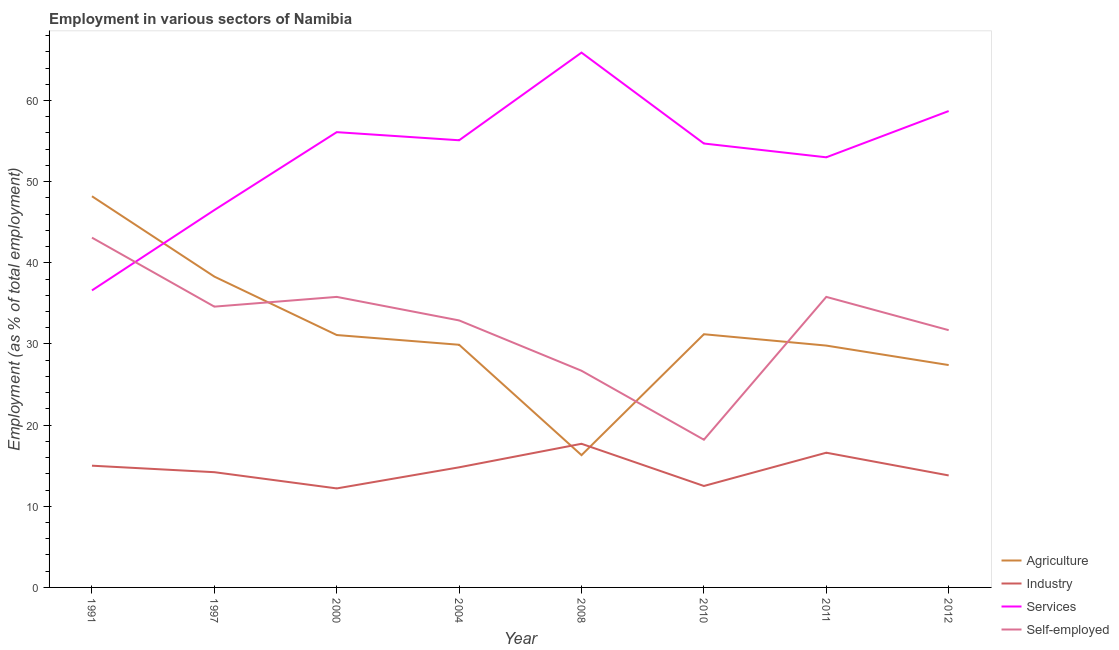How many different coloured lines are there?
Make the answer very short. 4. Is the number of lines equal to the number of legend labels?
Your answer should be very brief. Yes. What is the percentage of workers in industry in 2004?
Make the answer very short. 14.8. Across all years, what is the maximum percentage of workers in industry?
Provide a succinct answer. 17.7. Across all years, what is the minimum percentage of workers in services?
Offer a very short reply. 36.6. In which year was the percentage of workers in industry maximum?
Provide a short and direct response. 2008. What is the total percentage of workers in services in the graph?
Your answer should be very brief. 426.6. What is the difference between the percentage of workers in industry in 2008 and that in 2012?
Your response must be concise. 3.9. What is the difference between the percentage of workers in services in 1997 and the percentage of workers in agriculture in 2008?
Offer a terse response. 30.2. What is the average percentage of self employed workers per year?
Offer a very short reply. 32.35. In the year 2010, what is the difference between the percentage of workers in services and percentage of workers in industry?
Make the answer very short. 42.2. What is the ratio of the percentage of self employed workers in 1991 to that in 2000?
Your answer should be compact. 1.2. Is the percentage of workers in agriculture in 2010 less than that in 2011?
Give a very brief answer. No. Is the difference between the percentage of workers in services in 1991 and 2010 greater than the difference between the percentage of self employed workers in 1991 and 2010?
Provide a short and direct response. No. What is the difference between the highest and the second highest percentage of workers in services?
Provide a succinct answer. 7.2. What is the difference between the highest and the lowest percentage of workers in agriculture?
Make the answer very short. 31.9. In how many years, is the percentage of self employed workers greater than the average percentage of self employed workers taken over all years?
Offer a very short reply. 5. Is the sum of the percentage of workers in services in 1991 and 2012 greater than the maximum percentage of workers in industry across all years?
Provide a short and direct response. Yes. How many years are there in the graph?
Your answer should be very brief. 8. Does the graph contain grids?
Your answer should be compact. No. How are the legend labels stacked?
Keep it short and to the point. Vertical. What is the title of the graph?
Your response must be concise. Employment in various sectors of Namibia. Does "Subsidies and Transfers" appear as one of the legend labels in the graph?
Keep it short and to the point. No. What is the label or title of the X-axis?
Provide a succinct answer. Year. What is the label or title of the Y-axis?
Keep it short and to the point. Employment (as % of total employment). What is the Employment (as % of total employment) of Agriculture in 1991?
Offer a very short reply. 48.2. What is the Employment (as % of total employment) of Industry in 1991?
Offer a very short reply. 15. What is the Employment (as % of total employment) in Services in 1991?
Ensure brevity in your answer.  36.6. What is the Employment (as % of total employment) in Self-employed in 1991?
Provide a short and direct response. 43.1. What is the Employment (as % of total employment) in Agriculture in 1997?
Provide a short and direct response. 38.3. What is the Employment (as % of total employment) of Industry in 1997?
Give a very brief answer. 14.2. What is the Employment (as % of total employment) of Services in 1997?
Keep it short and to the point. 46.5. What is the Employment (as % of total employment) of Self-employed in 1997?
Your response must be concise. 34.6. What is the Employment (as % of total employment) of Agriculture in 2000?
Make the answer very short. 31.1. What is the Employment (as % of total employment) in Industry in 2000?
Provide a short and direct response. 12.2. What is the Employment (as % of total employment) of Services in 2000?
Keep it short and to the point. 56.1. What is the Employment (as % of total employment) of Self-employed in 2000?
Your answer should be very brief. 35.8. What is the Employment (as % of total employment) in Agriculture in 2004?
Your answer should be compact. 29.9. What is the Employment (as % of total employment) in Industry in 2004?
Give a very brief answer. 14.8. What is the Employment (as % of total employment) of Services in 2004?
Offer a terse response. 55.1. What is the Employment (as % of total employment) of Self-employed in 2004?
Offer a very short reply. 32.9. What is the Employment (as % of total employment) in Agriculture in 2008?
Ensure brevity in your answer.  16.3. What is the Employment (as % of total employment) of Industry in 2008?
Offer a very short reply. 17.7. What is the Employment (as % of total employment) of Services in 2008?
Ensure brevity in your answer.  65.9. What is the Employment (as % of total employment) of Self-employed in 2008?
Your answer should be compact. 26.7. What is the Employment (as % of total employment) in Agriculture in 2010?
Provide a succinct answer. 31.2. What is the Employment (as % of total employment) in Services in 2010?
Offer a terse response. 54.7. What is the Employment (as % of total employment) in Self-employed in 2010?
Offer a terse response. 18.2. What is the Employment (as % of total employment) in Agriculture in 2011?
Make the answer very short. 29.8. What is the Employment (as % of total employment) in Industry in 2011?
Ensure brevity in your answer.  16.6. What is the Employment (as % of total employment) in Services in 2011?
Keep it short and to the point. 53. What is the Employment (as % of total employment) of Self-employed in 2011?
Ensure brevity in your answer.  35.8. What is the Employment (as % of total employment) of Agriculture in 2012?
Offer a terse response. 27.4. What is the Employment (as % of total employment) of Industry in 2012?
Your answer should be very brief. 13.8. What is the Employment (as % of total employment) of Services in 2012?
Your answer should be very brief. 58.7. What is the Employment (as % of total employment) in Self-employed in 2012?
Your answer should be very brief. 31.7. Across all years, what is the maximum Employment (as % of total employment) of Agriculture?
Give a very brief answer. 48.2. Across all years, what is the maximum Employment (as % of total employment) in Industry?
Your answer should be compact. 17.7. Across all years, what is the maximum Employment (as % of total employment) of Services?
Ensure brevity in your answer.  65.9. Across all years, what is the maximum Employment (as % of total employment) in Self-employed?
Your response must be concise. 43.1. Across all years, what is the minimum Employment (as % of total employment) of Agriculture?
Your response must be concise. 16.3. Across all years, what is the minimum Employment (as % of total employment) in Industry?
Your response must be concise. 12.2. Across all years, what is the minimum Employment (as % of total employment) of Services?
Make the answer very short. 36.6. Across all years, what is the minimum Employment (as % of total employment) in Self-employed?
Your answer should be compact. 18.2. What is the total Employment (as % of total employment) of Agriculture in the graph?
Give a very brief answer. 252.2. What is the total Employment (as % of total employment) in Industry in the graph?
Ensure brevity in your answer.  116.8. What is the total Employment (as % of total employment) of Services in the graph?
Provide a succinct answer. 426.6. What is the total Employment (as % of total employment) in Self-employed in the graph?
Your answer should be very brief. 258.8. What is the difference between the Employment (as % of total employment) of Agriculture in 1991 and that in 1997?
Ensure brevity in your answer.  9.9. What is the difference between the Employment (as % of total employment) of Services in 1991 and that in 1997?
Offer a very short reply. -9.9. What is the difference between the Employment (as % of total employment) in Agriculture in 1991 and that in 2000?
Offer a terse response. 17.1. What is the difference between the Employment (as % of total employment) in Industry in 1991 and that in 2000?
Make the answer very short. 2.8. What is the difference between the Employment (as % of total employment) of Services in 1991 and that in 2000?
Make the answer very short. -19.5. What is the difference between the Employment (as % of total employment) in Self-employed in 1991 and that in 2000?
Make the answer very short. 7.3. What is the difference between the Employment (as % of total employment) of Industry in 1991 and that in 2004?
Provide a short and direct response. 0.2. What is the difference between the Employment (as % of total employment) of Services in 1991 and that in 2004?
Your answer should be very brief. -18.5. What is the difference between the Employment (as % of total employment) of Self-employed in 1991 and that in 2004?
Your response must be concise. 10.2. What is the difference between the Employment (as % of total employment) of Agriculture in 1991 and that in 2008?
Ensure brevity in your answer.  31.9. What is the difference between the Employment (as % of total employment) of Services in 1991 and that in 2008?
Your answer should be very brief. -29.3. What is the difference between the Employment (as % of total employment) of Agriculture in 1991 and that in 2010?
Provide a succinct answer. 17. What is the difference between the Employment (as % of total employment) of Services in 1991 and that in 2010?
Offer a very short reply. -18.1. What is the difference between the Employment (as % of total employment) in Self-employed in 1991 and that in 2010?
Ensure brevity in your answer.  24.9. What is the difference between the Employment (as % of total employment) in Industry in 1991 and that in 2011?
Provide a succinct answer. -1.6. What is the difference between the Employment (as % of total employment) of Services in 1991 and that in 2011?
Provide a short and direct response. -16.4. What is the difference between the Employment (as % of total employment) in Agriculture in 1991 and that in 2012?
Offer a very short reply. 20.8. What is the difference between the Employment (as % of total employment) in Services in 1991 and that in 2012?
Offer a very short reply. -22.1. What is the difference between the Employment (as % of total employment) in Self-employed in 1991 and that in 2012?
Provide a short and direct response. 11.4. What is the difference between the Employment (as % of total employment) of Industry in 1997 and that in 2004?
Offer a very short reply. -0.6. What is the difference between the Employment (as % of total employment) in Services in 1997 and that in 2004?
Your answer should be compact. -8.6. What is the difference between the Employment (as % of total employment) of Self-employed in 1997 and that in 2004?
Offer a terse response. 1.7. What is the difference between the Employment (as % of total employment) in Services in 1997 and that in 2008?
Your answer should be very brief. -19.4. What is the difference between the Employment (as % of total employment) of Industry in 1997 and that in 2010?
Give a very brief answer. 1.7. What is the difference between the Employment (as % of total employment) of Agriculture in 1997 and that in 2011?
Your answer should be compact. 8.5. What is the difference between the Employment (as % of total employment) in Self-employed in 1997 and that in 2011?
Offer a terse response. -1.2. What is the difference between the Employment (as % of total employment) in Agriculture in 1997 and that in 2012?
Ensure brevity in your answer.  10.9. What is the difference between the Employment (as % of total employment) in Services in 1997 and that in 2012?
Keep it short and to the point. -12.2. What is the difference between the Employment (as % of total employment) in Agriculture in 2000 and that in 2004?
Offer a very short reply. 1.2. What is the difference between the Employment (as % of total employment) of Agriculture in 2000 and that in 2008?
Offer a terse response. 14.8. What is the difference between the Employment (as % of total employment) in Agriculture in 2000 and that in 2010?
Keep it short and to the point. -0.1. What is the difference between the Employment (as % of total employment) of Services in 2000 and that in 2010?
Provide a succinct answer. 1.4. What is the difference between the Employment (as % of total employment) of Agriculture in 2000 and that in 2012?
Your answer should be compact. 3.7. What is the difference between the Employment (as % of total employment) in Industry in 2000 and that in 2012?
Offer a terse response. -1.6. What is the difference between the Employment (as % of total employment) in Services in 2000 and that in 2012?
Provide a short and direct response. -2.6. What is the difference between the Employment (as % of total employment) of Self-employed in 2000 and that in 2012?
Your answer should be compact. 4.1. What is the difference between the Employment (as % of total employment) of Industry in 2004 and that in 2008?
Offer a very short reply. -2.9. What is the difference between the Employment (as % of total employment) in Services in 2004 and that in 2008?
Keep it short and to the point. -10.8. What is the difference between the Employment (as % of total employment) in Self-employed in 2004 and that in 2008?
Make the answer very short. 6.2. What is the difference between the Employment (as % of total employment) of Agriculture in 2004 and that in 2010?
Provide a short and direct response. -1.3. What is the difference between the Employment (as % of total employment) in Industry in 2004 and that in 2010?
Your response must be concise. 2.3. What is the difference between the Employment (as % of total employment) of Agriculture in 2004 and that in 2011?
Keep it short and to the point. 0.1. What is the difference between the Employment (as % of total employment) in Industry in 2004 and that in 2011?
Provide a succinct answer. -1.8. What is the difference between the Employment (as % of total employment) of Self-employed in 2004 and that in 2011?
Make the answer very short. -2.9. What is the difference between the Employment (as % of total employment) in Agriculture in 2004 and that in 2012?
Offer a very short reply. 2.5. What is the difference between the Employment (as % of total employment) in Services in 2004 and that in 2012?
Keep it short and to the point. -3.6. What is the difference between the Employment (as % of total employment) in Agriculture in 2008 and that in 2010?
Keep it short and to the point. -14.9. What is the difference between the Employment (as % of total employment) in Industry in 2008 and that in 2010?
Ensure brevity in your answer.  5.2. What is the difference between the Employment (as % of total employment) in Services in 2008 and that in 2010?
Give a very brief answer. 11.2. What is the difference between the Employment (as % of total employment) of Agriculture in 2008 and that in 2012?
Your answer should be compact. -11.1. What is the difference between the Employment (as % of total employment) in Self-employed in 2008 and that in 2012?
Your answer should be very brief. -5. What is the difference between the Employment (as % of total employment) in Self-employed in 2010 and that in 2011?
Your response must be concise. -17.6. What is the difference between the Employment (as % of total employment) of Services in 2011 and that in 2012?
Keep it short and to the point. -5.7. What is the difference between the Employment (as % of total employment) in Self-employed in 2011 and that in 2012?
Give a very brief answer. 4.1. What is the difference between the Employment (as % of total employment) in Agriculture in 1991 and the Employment (as % of total employment) in Industry in 1997?
Your response must be concise. 34. What is the difference between the Employment (as % of total employment) of Agriculture in 1991 and the Employment (as % of total employment) of Self-employed in 1997?
Your response must be concise. 13.6. What is the difference between the Employment (as % of total employment) in Industry in 1991 and the Employment (as % of total employment) in Services in 1997?
Make the answer very short. -31.5. What is the difference between the Employment (as % of total employment) in Industry in 1991 and the Employment (as % of total employment) in Self-employed in 1997?
Your answer should be very brief. -19.6. What is the difference between the Employment (as % of total employment) of Services in 1991 and the Employment (as % of total employment) of Self-employed in 1997?
Your answer should be very brief. 2. What is the difference between the Employment (as % of total employment) of Agriculture in 1991 and the Employment (as % of total employment) of Services in 2000?
Your response must be concise. -7.9. What is the difference between the Employment (as % of total employment) in Industry in 1991 and the Employment (as % of total employment) in Services in 2000?
Give a very brief answer. -41.1. What is the difference between the Employment (as % of total employment) in Industry in 1991 and the Employment (as % of total employment) in Self-employed in 2000?
Your response must be concise. -20.8. What is the difference between the Employment (as % of total employment) of Agriculture in 1991 and the Employment (as % of total employment) of Industry in 2004?
Give a very brief answer. 33.4. What is the difference between the Employment (as % of total employment) of Agriculture in 1991 and the Employment (as % of total employment) of Self-employed in 2004?
Keep it short and to the point. 15.3. What is the difference between the Employment (as % of total employment) in Industry in 1991 and the Employment (as % of total employment) in Services in 2004?
Offer a terse response. -40.1. What is the difference between the Employment (as % of total employment) of Industry in 1991 and the Employment (as % of total employment) of Self-employed in 2004?
Offer a very short reply. -17.9. What is the difference between the Employment (as % of total employment) of Services in 1991 and the Employment (as % of total employment) of Self-employed in 2004?
Provide a short and direct response. 3.7. What is the difference between the Employment (as % of total employment) in Agriculture in 1991 and the Employment (as % of total employment) in Industry in 2008?
Provide a short and direct response. 30.5. What is the difference between the Employment (as % of total employment) in Agriculture in 1991 and the Employment (as % of total employment) in Services in 2008?
Ensure brevity in your answer.  -17.7. What is the difference between the Employment (as % of total employment) of Agriculture in 1991 and the Employment (as % of total employment) of Self-employed in 2008?
Give a very brief answer. 21.5. What is the difference between the Employment (as % of total employment) in Industry in 1991 and the Employment (as % of total employment) in Services in 2008?
Offer a terse response. -50.9. What is the difference between the Employment (as % of total employment) of Services in 1991 and the Employment (as % of total employment) of Self-employed in 2008?
Your answer should be compact. 9.9. What is the difference between the Employment (as % of total employment) of Agriculture in 1991 and the Employment (as % of total employment) of Industry in 2010?
Your answer should be very brief. 35.7. What is the difference between the Employment (as % of total employment) in Agriculture in 1991 and the Employment (as % of total employment) in Services in 2010?
Make the answer very short. -6.5. What is the difference between the Employment (as % of total employment) in Industry in 1991 and the Employment (as % of total employment) in Services in 2010?
Provide a short and direct response. -39.7. What is the difference between the Employment (as % of total employment) in Services in 1991 and the Employment (as % of total employment) in Self-employed in 2010?
Offer a terse response. 18.4. What is the difference between the Employment (as % of total employment) of Agriculture in 1991 and the Employment (as % of total employment) of Industry in 2011?
Your response must be concise. 31.6. What is the difference between the Employment (as % of total employment) in Agriculture in 1991 and the Employment (as % of total employment) in Services in 2011?
Provide a short and direct response. -4.8. What is the difference between the Employment (as % of total employment) in Agriculture in 1991 and the Employment (as % of total employment) in Self-employed in 2011?
Keep it short and to the point. 12.4. What is the difference between the Employment (as % of total employment) of Industry in 1991 and the Employment (as % of total employment) of Services in 2011?
Provide a succinct answer. -38. What is the difference between the Employment (as % of total employment) in Industry in 1991 and the Employment (as % of total employment) in Self-employed in 2011?
Offer a very short reply. -20.8. What is the difference between the Employment (as % of total employment) in Agriculture in 1991 and the Employment (as % of total employment) in Industry in 2012?
Ensure brevity in your answer.  34.4. What is the difference between the Employment (as % of total employment) of Agriculture in 1991 and the Employment (as % of total employment) of Services in 2012?
Offer a terse response. -10.5. What is the difference between the Employment (as % of total employment) in Industry in 1991 and the Employment (as % of total employment) in Services in 2012?
Provide a short and direct response. -43.7. What is the difference between the Employment (as % of total employment) in Industry in 1991 and the Employment (as % of total employment) in Self-employed in 2012?
Provide a short and direct response. -16.7. What is the difference between the Employment (as % of total employment) of Services in 1991 and the Employment (as % of total employment) of Self-employed in 2012?
Keep it short and to the point. 4.9. What is the difference between the Employment (as % of total employment) in Agriculture in 1997 and the Employment (as % of total employment) in Industry in 2000?
Keep it short and to the point. 26.1. What is the difference between the Employment (as % of total employment) of Agriculture in 1997 and the Employment (as % of total employment) of Services in 2000?
Give a very brief answer. -17.8. What is the difference between the Employment (as % of total employment) in Agriculture in 1997 and the Employment (as % of total employment) in Self-employed in 2000?
Your response must be concise. 2.5. What is the difference between the Employment (as % of total employment) of Industry in 1997 and the Employment (as % of total employment) of Services in 2000?
Your answer should be very brief. -41.9. What is the difference between the Employment (as % of total employment) of Industry in 1997 and the Employment (as % of total employment) of Self-employed in 2000?
Keep it short and to the point. -21.6. What is the difference between the Employment (as % of total employment) of Agriculture in 1997 and the Employment (as % of total employment) of Services in 2004?
Make the answer very short. -16.8. What is the difference between the Employment (as % of total employment) in Industry in 1997 and the Employment (as % of total employment) in Services in 2004?
Keep it short and to the point. -40.9. What is the difference between the Employment (as % of total employment) in Industry in 1997 and the Employment (as % of total employment) in Self-employed in 2004?
Make the answer very short. -18.7. What is the difference between the Employment (as % of total employment) in Agriculture in 1997 and the Employment (as % of total employment) in Industry in 2008?
Ensure brevity in your answer.  20.6. What is the difference between the Employment (as % of total employment) of Agriculture in 1997 and the Employment (as % of total employment) of Services in 2008?
Your response must be concise. -27.6. What is the difference between the Employment (as % of total employment) of Agriculture in 1997 and the Employment (as % of total employment) of Self-employed in 2008?
Offer a very short reply. 11.6. What is the difference between the Employment (as % of total employment) in Industry in 1997 and the Employment (as % of total employment) in Services in 2008?
Offer a very short reply. -51.7. What is the difference between the Employment (as % of total employment) in Services in 1997 and the Employment (as % of total employment) in Self-employed in 2008?
Keep it short and to the point. 19.8. What is the difference between the Employment (as % of total employment) of Agriculture in 1997 and the Employment (as % of total employment) of Industry in 2010?
Ensure brevity in your answer.  25.8. What is the difference between the Employment (as % of total employment) in Agriculture in 1997 and the Employment (as % of total employment) in Services in 2010?
Your response must be concise. -16.4. What is the difference between the Employment (as % of total employment) in Agriculture in 1997 and the Employment (as % of total employment) in Self-employed in 2010?
Your answer should be very brief. 20.1. What is the difference between the Employment (as % of total employment) of Industry in 1997 and the Employment (as % of total employment) of Services in 2010?
Provide a succinct answer. -40.5. What is the difference between the Employment (as % of total employment) of Industry in 1997 and the Employment (as % of total employment) of Self-employed in 2010?
Offer a terse response. -4. What is the difference between the Employment (as % of total employment) in Services in 1997 and the Employment (as % of total employment) in Self-employed in 2010?
Ensure brevity in your answer.  28.3. What is the difference between the Employment (as % of total employment) of Agriculture in 1997 and the Employment (as % of total employment) of Industry in 2011?
Keep it short and to the point. 21.7. What is the difference between the Employment (as % of total employment) in Agriculture in 1997 and the Employment (as % of total employment) in Services in 2011?
Provide a succinct answer. -14.7. What is the difference between the Employment (as % of total employment) in Industry in 1997 and the Employment (as % of total employment) in Services in 2011?
Ensure brevity in your answer.  -38.8. What is the difference between the Employment (as % of total employment) in Industry in 1997 and the Employment (as % of total employment) in Self-employed in 2011?
Provide a succinct answer. -21.6. What is the difference between the Employment (as % of total employment) in Agriculture in 1997 and the Employment (as % of total employment) in Industry in 2012?
Give a very brief answer. 24.5. What is the difference between the Employment (as % of total employment) of Agriculture in 1997 and the Employment (as % of total employment) of Services in 2012?
Make the answer very short. -20.4. What is the difference between the Employment (as % of total employment) of Agriculture in 1997 and the Employment (as % of total employment) of Self-employed in 2012?
Your answer should be compact. 6.6. What is the difference between the Employment (as % of total employment) in Industry in 1997 and the Employment (as % of total employment) in Services in 2012?
Offer a very short reply. -44.5. What is the difference between the Employment (as % of total employment) of Industry in 1997 and the Employment (as % of total employment) of Self-employed in 2012?
Keep it short and to the point. -17.5. What is the difference between the Employment (as % of total employment) of Services in 1997 and the Employment (as % of total employment) of Self-employed in 2012?
Provide a short and direct response. 14.8. What is the difference between the Employment (as % of total employment) of Agriculture in 2000 and the Employment (as % of total employment) of Services in 2004?
Offer a terse response. -24. What is the difference between the Employment (as % of total employment) in Industry in 2000 and the Employment (as % of total employment) in Services in 2004?
Make the answer very short. -42.9. What is the difference between the Employment (as % of total employment) in Industry in 2000 and the Employment (as % of total employment) in Self-employed in 2004?
Provide a short and direct response. -20.7. What is the difference between the Employment (as % of total employment) in Services in 2000 and the Employment (as % of total employment) in Self-employed in 2004?
Make the answer very short. 23.2. What is the difference between the Employment (as % of total employment) in Agriculture in 2000 and the Employment (as % of total employment) in Industry in 2008?
Offer a terse response. 13.4. What is the difference between the Employment (as % of total employment) in Agriculture in 2000 and the Employment (as % of total employment) in Services in 2008?
Give a very brief answer. -34.8. What is the difference between the Employment (as % of total employment) in Agriculture in 2000 and the Employment (as % of total employment) in Self-employed in 2008?
Provide a short and direct response. 4.4. What is the difference between the Employment (as % of total employment) in Industry in 2000 and the Employment (as % of total employment) in Services in 2008?
Make the answer very short. -53.7. What is the difference between the Employment (as % of total employment) in Services in 2000 and the Employment (as % of total employment) in Self-employed in 2008?
Provide a succinct answer. 29.4. What is the difference between the Employment (as % of total employment) of Agriculture in 2000 and the Employment (as % of total employment) of Industry in 2010?
Your response must be concise. 18.6. What is the difference between the Employment (as % of total employment) in Agriculture in 2000 and the Employment (as % of total employment) in Services in 2010?
Offer a very short reply. -23.6. What is the difference between the Employment (as % of total employment) of Industry in 2000 and the Employment (as % of total employment) of Services in 2010?
Your response must be concise. -42.5. What is the difference between the Employment (as % of total employment) in Services in 2000 and the Employment (as % of total employment) in Self-employed in 2010?
Provide a short and direct response. 37.9. What is the difference between the Employment (as % of total employment) of Agriculture in 2000 and the Employment (as % of total employment) of Industry in 2011?
Provide a succinct answer. 14.5. What is the difference between the Employment (as % of total employment) in Agriculture in 2000 and the Employment (as % of total employment) in Services in 2011?
Offer a very short reply. -21.9. What is the difference between the Employment (as % of total employment) in Industry in 2000 and the Employment (as % of total employment) in Services in 2011?
Make the answer very short. -40.8. What is the difference between the Employment (as % of total employment) in Industry in 2000 and the Employment (as % of total employment) in Self-employed in 2011?
Keep it short and to the point. -23.6. What is the difference between the Employment (as % of total employment) of Services in 2000 and the Employment (as % of total employment) of Self-employed in 2011?
Provide a short and direct response. 20.3. What is the difference between the Employment (as % of total employment) in Agriculture in 2000 and the Employment (as % of total employment) in Services in 2012?
Offer a terse response. -27.6. What is the difference between the Employment (as % of total employment) of Industry in 2000 and the Employment (as % of total employment) of Services in 2012?
Your answer should be very brief. -46.5. What is the difference between the Employment (as % of total employment) in Industry in 2000 and the Employment (as % of total employment) in Self-employed in 2012?
Offer a very short reply. -19.5. What is the difference between the Employment (as % of total employment) in Services in 2000 and the Employment (as % of total employment) in Self-employed in 2012?
Give a very brief answer. 24.4. What is the difference between the Employment (as % of total employment) of Agriculture in 2004 and the Employment (as % of total employment) of Services in 2008?
Your response must be concise. -36. What is the difference between the Employment (as % of total employment) in Industry in 2004 and the Employment (as % of total employment) in Services in 2008?
Your answer should be compact. -51.1. What is the difference between the Employment (as % of total employment) of Industry in 2004 and the Employment (as % of total employment) of Self-employed in 2008?
Make the answer very short. -11.9. What is the difference between the Employment (as % of total employment) in Services in 2004 and the Employment (as % of total employment) in Self-employed in 2008?
Your response must be concise. 28.4. What is the difference between the Employment (as % of total employment) of Agriculture in 2004 and the Employment (as % of total employment) of Services in 2010?
Make the answer very short. -24.8. What is the difference between the Employment (as % of total employment) in Agriculture in 2004 and the Employment (as % of total employment) in Self-employed in 2010?
Your answer should be very brief. 11.7. What is the difference between the Employment (as % of total employment) in Industry in 2004 and the Employment (as % of total employment) in Services in 2010?
Make the answer very short. -39.9. What is the difference between the Employment (as % of total employment) in Services in 2004 and the Employment (as % of total employment) in Self-employed in 2010?
Your answer should be compact. 36.9. What is the difference between the Employment (as % of total employment) of Agriculture in 2004 and the Employment (as % of total employment) of Services in 2011?
Offer a very short reply. -23.1. What is the difference between the Employment (as % of total employment) of Industry in 2004 and the Employment (as % of total employment) of Services in 2011?
Offer a terse response. -38.2. What is the difference between the Employment (as % of total employment) of Services in 2004 and the Employment (as % of total employment) of Self-employed in 2011?
Offer a terse response. 19.3. What is the difference between the Employment (as % of total employment) of Agriculture in 2004 and the Employment (as % of total employment) of Services in 2012?
Provide a succinct answer. -28.8. What is the difference between the Employment (as % of total employment) of Agriculture in 2004 and the Employment (as % of total employment) of Self-employed in 2012?
Your answer should be very brief. -1.8. What is the difference between the Employment (as % of total employment) of Industry in 2004 and the Employment (as % of total employment) of Services in 2012?
Keep it short and to the point. -43.9. What is the difference between the Employment (as % of total employment) of Industry in 2004 and the Employment (as % of total employment) of Self-employed in 2012?
Ensure brevity in your answer.  -16.9. What is the difference between the Employment (as % of total employment) in Services in 2004 and the Employment (as % of total employment) in Self-employed in 2012?
Provide a succinct answer. 23.4. What is the difference between the Employment (as % of total employment) in Agriculture in 2008 and the Employment (as % of total employment) in Industry in 2010?
Your answer should be very brief. 3.8. What is the difference between the Employment (as % of total employment) in Agriculture in 2008 and the Employment (as % of total employment) in Services in 2010?
Your answer should be compact. -38.4. What is the difference between the Employment (as % of total employment) in Agriculture in 2008 and the Employment (as % of total employment) in Self-employed in 2010?
Provide a succinct answer. -1.9. What is the difference between the Employment (as % of total employment) in Industry in 2008 and the Employment (as % of total employment) in Services in 2010?
Offer a very short reply. -37. What is the difference between the Employment (as % of total employment) in Services in 2008 and the Employment (as % of total employment) in Self-employed in 2010?
Ensure brevity in your answer.  47.7. What is the difference between the Employment (as % of total employment) of Agriculture in 2008 and the Employment (as % of total employment) of Services in 2011?
Ensure brevity in your answer.  -36.7. What is the difference between the Employment (as % of total employment) of Agriculture in 2008 and the Employment (as % of total employment) of Self-employed in 2011?
Provide a short and direct response. -19.5. What is the difference between the Employment (as % of total employment) of Industry in 2008 and the Employment (as % of total employment) of Services in 2011?
Offer a terse response. -35.3. What is the difference between the Employment (as % of total employment) of Industry in 2008 and the Employment (as % of total employment) of Self-employed in 2011?
Offer a very short reply. -18.1. What is the difference between the Employment (as % of total employment) of Services in 2008 and the Employment (as % of total employment) of Self-employed in 2011?
Provide a succinct answer. 30.1. What is the difference between the Employment (as % of total employment) of Agriculture in 2008 and the Employment (as % of total employment) of Industry in 2012?
Offer a very short reply. 2.5. What is the difference between the Employment (as % of total employment) in Agriculture in 2008 and the Employment (as % of total employment) in Services in 2012?
Your response must be concise. -42.4. What is the difference between the Employment (as % of total employment) of Agriculture in 2008 and the Employment (as % of total employment) of Self-employed in 2012?
Keep it short and to the point. -15.4. What is the difference between the Employment (as % of total employment) of Industry in 2008 and the Employment (as % of total employment) of Services in 2012?
Give a very brief answer. -41. What is the difference between the Employment (as % of total employment) of Industry in 2008 and the Employment (as % of total employment) of Self-employed in 2012?
Ensure brevity in your answer.  -14. What is the difference between the Employment (as % of total employment) in Services in 2008 and the Employment (as % of total employment) in Self-employed in 2012?
Your answer should be very brief. 34.2. What is the difference between the Employment (as % of total employment) of Agriculture in 2010 and the Employment (as % of total employment) of Industry in 2011?
Offer a very short reply. 14.6. What is the difference between the Employment (as % of total employment) of Agriculture in 2010 and the Employment (as % of total employment) of Services in 2011?
Ensure brevity in your answer.  -21.8. What is the difference between the Employment (as % of total employment) of Industry in 2010 and the Employment (as % of total employment) of Services in 2011?
Provide a short and direct response. -40.5. What is the difference between the Employment (as % of total employment) in Industry in 2010 and the Employment (as % of total employment) in Self-employed in 2011?
Your answer should be very brief. -23.3. What is the difference between the Employment (as % of total employment) of Agriculture in 2010 and the Employment (as % of total employment) of Industry in 2012?
Provide a short and direct response. 17.4. What is the difference between the Employment (as % of total employment) of Agriculture in 2010 and the Employment (as % of total employment) of Services in 2012?
Offer a very short reply. -27.5. What is the difference between the Employment (as % of total employment) in Agriculture in 2010 and the Employment (as % of total employment) in Self-employed in 2012?
Your answer should be compact. -0.5. What is the difference between the Employment (as % of total employment) in Industry in 2010 and the Employment (as % of total employment) in Services in 2012?
Offer a very short reply. -46.2. What is the difference between the Employment (as % of total employment) of Industry in 2010 and the Employment (as % of total employment) of Self-employed in 2012?
Offer a terse response. -19.2. What is the difference between the Employment (as % of total employment) of Agriculture in 2011 and the Employment (as % of total employment) of Services in 2012?
Provide a succinct answer. -28.9. What is the difference between the Employment (as % of total employment) in Industry in 2011 and the Employment (as % of total employment) in Services in 2012?
Keep it short and to the point. -42.1. What is the difference between the Employment (as % of total employment) of Industry in 2011 and the Employment (as % of total employment) of Self-employed in 2012?
Your answer should be compact. -15.1. What is the difference between the Employment (as % of total employment) in Services in 2011 and the Employment (as % of total employment) in Self-employed in 2012?
Offer a terse response. 21.3. What is the average Employment (as % of total employment) in Agriculture per year?
Your response must be concise. 31.52. What is the average Employment (as % of total employment) in Services per year?
Ensure brevity in your answer.  53.33. What is the average Employment (as % of total employment) in Self-employed per year?
Offer a terse response. 32.35. In the year 1991, what is the difference between the Employment (as % of total employment) in Agriculture and Employment (as % of total employment) in Industry?
Your answer should be very brief. 33.2. In the year 1991, what is the difference between the Employment (as % of total employment) in Agriculture and Employment (as % of total employment) in Services?
Keep it short and to the point. 11.6. In the year 1991, what is the difference between the Employment (as % of total employment) of Industry and Employment (as % of total employment) of Services?
Provide a short and direct response. -21.6. In the year 1991, what is the difference between the Employment (as % of total employment) of Industry and Employment (as % of total employment) of Self-employed?
Offer a terse response. -28.1. In the year 1991, what is the difference between the Employment (as % of total employment) in Services and Employment (as % of total employment) in Self-employed?
Provide a short and direct response. -6.5. In the year 1997, what is the difference between the Employment (as % of total employment) in Agriculture and Employment (as % of total employment) in Industry?
Keep it short and to the point. 24.1. In the year 1997, what is the difference between the Employment (as % of total employment) of Agriculture and Employment (as % of total employment) of Services?
Your response must be concise. -8.2. In the year 1997, what is the difference between the Employment (as % of total employment) in Agriculture and Employment (as % of total employment) in Self-employed?
Make the answer very short. 3.7. In the year 1997, what is the difference between the Employment (as % of total employment) of Industry and Employment (as % of total employment) of Services?
Ensure brevity in your answer.  -32.3. In the year 1997, what is the difference between the Employment (as % of total employment) of Industry and Employment (as % of total employment) of Self-employed?
Keep it short and to the point. -20.4. In the year 2000, what is the difference between the Employment (as % of total employment) in Agriculture and Employment (as % of total employment) in Industry?
Provide a short and direct response. 18.9. In the year 2000, what is the difference between the Employment (as % of total employment) of Industry and Employment (as % of total employment) of Services?
Provide a short and direct response. -43.9. In the year 2000, what is the difference between the Employment (as % of total employment) in Industry and Employment (as % of total employment) in Self-employed?
Your answer should be very brief. -23.6. In the year 2000, what is the difference between the Employment (as % of total employment) in Services and Employment (as % of total employment) in Self-employed?
Provide a short and direct response. 20.3. In the year 2004, what is the difference between the Employment (as % of total employment) of Agriculture and Employment (as % of total employment) of Industry?
Offer a terse response. 15.1. In the year 2004, what is the difference between the Employment (as % of total employment) of Agriculture and Employment (as % of total employment) of Services?
Give a very brief answer. -25.2. In the year 2004, what is the difference between the Employment (as % of total employment) in Industry and Employment (as % of total employment) in Services?
Ensure brevity in your answer.  -40.3. In the year 2004, what is the difference between the Employment (as % of total employment) of Industry and Employment (as % of total employment) of Self-employed?
Provide a short and direct response. -18.1. In the year 2008, what is the difference between the Employment (as % of total employment) of Agriculture and Employment (as % of total employment) of Industry?
Offer a terse response. -1.4. In the year 2008, what is the difference between the Employment (as % of total employment) in Agriculture and Employment (as % of total employment) in Services?
Your response must be concise. -49.6. In the year 2008, what is the difference between the Employment (as % of total employment) of Agriculture and Employment (as % of total employment) of Self-employed?
Keep it short and to the point. -10.4. In the year 2008, what is the difference between the Employment (as % of total employment) of Industry and Employment (as % of total employment) of Services?
Your answer should be compact. -48.2. In the year 2008, what is the difference between the Employment (as % of total employment) in Industry and Employment (as % of total employment) in Self-employed?
Provide a succinct answer. -9. In the year 2008, what is the difference between the Employment (as % of total employment) in Services and Employment (as % of total employment) in Self-employed?
Keep it short and to the point. 39.2. In the year 2010, what is the difference between the Employment (as % of total employment) in Agriculture and Employment (as % of total employment) in Services?
Your response must be concise. -23.5. In the year 2010, what is the difference between the Employment (as % of total employment) of Agriculture and Employment (as % of total employment) of Self-employed?
Provide a succinct answer. 13. In the year 2010, what is the difference between the Employment (as % of total employment) in Industry and Employment (as % of total employment) in Services?
Provide a short and direct response. -42.2. In the year 2010, what is the difference between the Employment (as % of total employment) of Industry and Employment (as % of total employment) of Self-employed?
Your answer should be compact. -5.7. In the year 2010, what is the difference between the Employment (as % of total employment) in Services and Employment (as % of total employment) in Self-employed?
Make the answer very short. 36.5. In the year 2011, what is the difference between the Employment (as % of total employment) of Agriculture and Employment (as % of total employment) of Services?
Provide a short and direct response. -23.2. In the year 2011, what is the difference between the Employment (as % of total employment) in Agriculture and Employment (as % of total employment) in Self-employed?
Offer a very short reply. -6. In the year 2011, what is the difference between the Employment (as % of total employment) in Industry and Employment (as % of total employment) in Services?
Make the answer very short. -36.4. In the year 2011, what is the difference between the Employment (as % of total employment) in Industry and Employment (as % of total employment) in Self-employed?
Keep it short and to the point. -19.2. In the year 2012, what is the difference between the Employment (as % of total employment) in Agriculture and Employment (as % of total employment) in Services?
Provide a short and direct response. -31.3. In the year 2012, what is the difference between the Employment (as % of total employment) in Agriculture and Employment (as % of total employment) in Self-employed?
Keep it short and to the point. -4.3. In the year 2012, what is the difference between the Employment (as % of total employment) of Industry and Employment (as % of total employment) of Services?
Your answer should be very brief. -44.9. In the year 2012, what is the difference between the Employment (as % of total employment) of Industry and Employment (as % of total employment) of Self-employed?
Your answer should be compact. -17.9. What is the ratio of the Employment (as % of total employment) in Agriculture in 1991 to that in 1997?
Provide a succinct answer. 1.26. What is the ratio of the Employment (as % of total employment) of Industry in 1991 to that in 1997?
Your answer should be compact. 1.06. What is the ratio of the Employment (as % of total employment) of Services in 1991 to that in 1997?
Your answer should be compact. 0.79. What is the ratio of the Employment (as % of total employment) in Self-employed in 1991 to that in 1997?
Your answer should be very brief. 1.25. What is the ratio of the Employment (as % of total employment) in Agriculture in 1991 to that in 2000?
Make the answer very short. 1.55. What is the ratio of the Employment (as % of total employment) of Industry in 1991 to that in 2000?
Provide a short and direct response. 1.23. What is the ratio of the Employment (as % of total employment) in Services in 1991 to that in 2000?
Ensure brevity in your answer.  0.65. What is the ratio of the Employment (as % of total employment) in Self-employed in 1991 to that in 2000?
Ensure brevity in your answer.  1.2. What is the ratio of the Employment (as % of total employment) of Agriculture in 1991 to that in 2004?
Keep it short and to the point. 1.61. What is the ratio of the Employment (as % of total employment) of Industry in 1991 to that in 2004?
Provide a short and direct response. 1.01. What is the ratio of the Employment (as % of total employment) in Services in 1991 to that in 2004?
Keep it short and to the point. 0.66. What is the ratio of the Employment (as % of total employment) of Self-employed in 1991 to that in 2004?
Ensure brevity in your answer.  1.31. What is the ratio of the Employment (as % of total employment) of Agriculture in 1991 to that in 2008?
Provide a succinct answer. 2.96. What is the ratio of the Employment (as % of total employment) of Industry in 1991 to that in 2008?
Your answer should be compact. 0.85. What is the ratio of the Employment (as % of total employment) of Services in 1991 to that in 2008?
Provide a succinct answer. 0.56. What is the ratio of the Employment (as % of total employment) of Self-employed in 1991 to that in 2008?
Give a very brief answer. 1.61. What is the ratio of the Employment (as % of total employment) of Agriculture in 1991 to that in 2010?
Ensure brevity in your answer.  1.54. What is the ratio of the Employment (as % of total employment) of Industry in 1991 to that in 2010?
Your answer should be very brief. 1.2. What is the ratio of the Employment (as % of total employment) in Services in 1991 to that in 2010?
Make the answer very short. 0.67. What is the ratio of the Employment (as % of total employment) of Self-employed in 1991 to that in 2010?
Offer a terse response. 2.37. What is the ratio of the Employment (as % of total employment) of Agriculture in 1991 to that in 2011?
Offer a very short reply. 1.62. What is the ratio of the Employment (as % of total employment) in Industry in 1991 to that in 2011?
Offer a very short reply. 0.9. What is the ratio of the Employment (as % of total employment) of Services in 1991 to that in 2011?
Your answer should be compact. 0.69. What is the ratio of the Employment (as % of total employment) in Self-employed in 1991 to that in 2011?
Offer a very short reply. 1.2. What is the ratio of the Employment (as % of total employment) in Agriculture in 1991 to that in 2012?
Ensure brevity in your answer.  1.76. What is the ratio of the Employment (as % of total employment) of Industry in 1991 to that in 2012?
Keep it short and to the point. 1.09. What is the ratio of the Employment (as % of total employment) of Services in 1991 to that in 2012?
Give a very brief answer. 0.62. What is the ratio of the Employment (as % of total employment) in Self-employed in 1991 to that in 2012?
Your answer should be very brief. 1.36. What is the ratio of the Employment (as % of total employment) in Agriculture in 1997 to that in 2000?
Your answer should be very brief. 1.23. What is the ratio of the Employment (as % of total employment) in Industry in 1997 to that in 2000?
Provide a short and direct response. 1.16. What is the ratio of the Employment (as % of total employment) in Services in 1997 to that in 2000?
Offer a terse response. 0.83. What is the ratio of the Employment (as % of total employment) in Self-employed in 1997 to that in 2000?
Your answer should be very brief. 0.97. What is the ratio of the Employment (as % of total employment) of Agriculture in 1997 to that in 2004?
Make the answer very short. 1.28. What is the ratio of the Employment (as % of total employment) of Industry in 1997 to that in 2004?
Give a very brief answer. 0.96. What is the ratio of the Employment (as % of total employment) in Services in 1997 to that in 2004?
Give a very brief answer. 0.84. What is the ratio of the Employment (as % of total employment) in Self-employed in 1997 to that in 2004?
Your answer should be very brief. 1.05. What is the ratio of the Employment (as % of total employment) in Agriculture in 1997 to that in 2008?
Make the answer very short. 2.35. What is the ratio of the Employment (as % of total employment) in Industry in 1997 to that in 2008?
Your answer should be very brief. 0.8. What is the ratio of the Employment (as % of total employment) in Services in 1997 to that in 2008?
Offer a terse response. 0.71. What is the ratio of the Employment (as % of total employment) in Self-employed in 1997 to that in 2008?
Make the answer very short. 1.3. What is the ratio of the Employment (as % of total employment) of Agriculture in 1997 to that in 2010?
Ensure brevity in your answer.  1.23. What is the ratio of the Employment (as % of total employment) in Industry in 1997 to that in 2010?
Offer a terse response. 1.14. What is the ratio of the Employment (as % of total employment) of Services in 1997 to that in 2010?
Keep it short and to the point. 0.85. What is the ratio of the Employment (as % of total employment) of Self-employed in 1997 to that in 2010?
Make the answer very short. 1.9. What is the ratio of the Employment (as % of total employment) in Agriculture in 1997 to that in 2011?
Provide a short and direct response. 1.29. What is the ratio of the Employment (as % of total employment) in Industry in 1997 to that in 2011?
Make the answer very short. 0.86. What is the ratio of the Employment (as % of total employment) in Services in 1997 to that in 2011?
Your answer should be very brief. 0.88. What is the ratio of the Employment (as % of total employment) of Self-employed in 1997 to that in 2011?
Your answer should be very brief. 0.97. What is the ratio of the Employment (as % of total employment) of Agriculture in 1997 to that in 2012?
Offer a very short reply. 1.4. What is the ratio of the Employment (as % of total employment) in Industry in 1997 to that in 2012?
Ensure brevity in your answer.  1.03. What is the ratio of the Employment (as % of total employment) in Services in 1997 to that in 2012?
Provide a succinct answer. 0.79. What is the ratio of the Employment (as % of total employment) of Self-employed in 1997 to that in 2012?
Offer a very short reply. 1.09. What is the ratio of the Employment (as % of total employment) of Agriculture in 2000 to that in 2004?
Provide a short and direct response. 1.04. What is the ratio of the Employment (as % of total employment) in Industry in 2000 to that in 2004?
Provide a succinct answer. 0.82. What is the ratio of the Employment (as % of total employment) in Services in 2000 to that in 2004?
Your answer should be compact. 1.02. What is the ratio of the Employment (as % of total employment) in Self-employed in 2000 to that in 2004?
Provide a succinct answer. 1.09. What is the ratio of the Employment (as % of total employment) of Agriculture in 2000 to that in 2008?
Provide a succinct answer. 1.91. What is the ratio of the Employment (as % of total employment) of Industry in 2000 to that in 2008?
Ensure brevity in your answer.  0.69. What is the ratio of the Employment (as % of total employment) in Services in 2000 to that in 2008?
Provide a succinct answer. 0.85. What is the ratio of the Employment (as % of total employment) in Self-employed in 2000 to that in 2008?
Provide a short and direct response. 1.34. What is the ratio of the Employment (as % of total employment) of Agriculture in 2000 to that in 2010?
Give a very brief answer. 1. What is the ratio of the Employment (as % of total employment) in Industry in 2000 to that in 2010?
Provide a succinct answer. 0.98. What is the ratio of the Employment (as % of total employment) of Services in 2000 to that in 2010?
Keep it short and to the point. 1.03. What is the ratio of the Employment (as % of total employment) of Self-employed in 2000 to that in 2010?
Make the answer very short. 1.97. What is the ratio of the Employment (as % of total employment) of Agriculture in 2000 to that in 2011?
Offer a terse response. 1.04. What is the ratio of the Employment (as % of total employment) in Industry in 2000 to that in 2011?
Give a very brief answer. 0.73. What is the ratio of the Employment (as % of total employment) in Services in 2000 to that in 2011?
Your response must be concise. 1.06. What is the ratio of the Employment (as % of total employment) in Self-employed in 2000 to that in 2011?
Provide a succinct answer. 1. What is the ratio of the Employment (as % of total employment) of Agriculture in 2000 to that in 2012?
Your answer should be very brief. 1.14. What is the ratio of the Employment (as % of total employment) of Industry in 2000 to that in 2012?
Keep it short and to the point. 0.88. What is the ratio of the Employment (as % of total employment) of Services in 2000 to that in 2012?
Ensure brevity in your answer.  0.96. What is the ratio of the Employment (as % of total employment) in Self-employed in 2000 to that in 2012?
Provide a succinct answer. 1.13. What is the ratio of the Employment (as % of total employment) of Agriculture in 2004 to that in 2008?
Make the answer very short. 1.83. What is the ratio of the Employment (as % of total employment) of Industry in 2004 to that in 2008?
Keep it short and to the point. 0.84. What is the ratio of the Employment (as % of total employment) in Services in 2004 to that in 2008?
Provide a short and direct response. 0.84. What is the ratio of the Employment (as % of total employment) of Self-employed in 2004 to that in 2008?
Keep it short and to the point. 1.23. What is the ratio of the Employment (as % of total employment) in Industry in 2004 to that in 2010?
Offer a terse response. 1.18. What is the ratio of the Employment (as % of total employment) in Services in 2004 to that in 2010?
Your response must be concise. 1.01. What is the ratio of the Employment (as % of total employment) of Self-employed in 2004 to that in 2010?
Make the answer very short. 1.81. What is the ratio of the Employment (as % of total employment) of Industry in 2004 to that in 2011?
Offer a very short reply. 0.89. What is the ratio of the Employment (as % of total employment) in Services in 2004 to that in 2011?
Provide a succinct answer. 1.04. What is the ratio of the Employment (as % of total employment) of Self-employed in 2004 to that in 2011?
Offer a very short reply. 0.92. What is the ratio of the Employment (as % of total employment) in Agriculture in 2004 to that in 2012?
Give a very brief answer. 1.09. What is the ratio of the Employment (as % of total employment) in Industry in 2004 to that in 2012?
Give a very brief answer. 1.07. What is the ratio of the Employment (as % of total employment) of Services in 2004 to that in 2012?
Provide a succinct answer. 0.94. What is the ratio of the Employment (as % of total employment) in Self-employed in 2004 to that in 2012?
Keep it short and to the point. 1.04. What is the ratio of the Employment (as % of total employment) of Agriculture in 2008 to that in 2010?
Provide a succinct answer. 0.52. What is the ratio of the Employment (as % of total employment) in Industry in 2008 to that in 2010?
Ensure brevity in your answer.  1.42. What is the ratio of the Employment (as % of total employment) of Services in 2008 to that in 2010?
Keep it short and to the point. 1.2. What is the ratio of the Employment (as % of total employment) of Self-employed in 2008 to that in 2010?
Make the answer very short. 1.47. What is the ratio of the Employment (as % of total employment) in Agriculture in 2008 to that in 2011?
Offer a very short reply. 0.55. What is the ratio of the Employment (as % of total employment) in Industry in 2008 to that in 2011?
Provide a succinct answer. 1.07. What is the ratio of the Employment (as % of total employment) in Services in 2008 to that in 2011?
Give a very brief answer. 1.24. What is the ratio of the Employment (as % of total employment) of Self-employed in 2008 to that in 2011?
Your answer should be very brief. 0.75. What is the ratio of the Employment (as % of total employment) of Agriculture in 2008 to that in 2012?
Provide a short and direct response. 0.59. What is the ratio of the Employment (as % of total employment) of Industry in 2008 to that in 2012?
Make the answer very short. 1.28. What is the ratio of the Employment (as % of total employment) of Services in 2008 to that in 2012?
Make the answer very short. 1.12. What is the ratio of the Employment (as % of total employment) of Self-employed in 2008 to that in 2012?
Your response must be concise. 0.84. What is the ratio of the Employment (as % of total employment) in Agriculture in 2010 to that in 2011?
Give a very brief answer. 1.05. What is the ratio of the Employment (as % of total employment) in Industry in 2010 to that in 2011?
Make the answer very short. 0.75. What is the ratio of the Employment (as % of total employment) of Services in 2010 to that in 2011?
Provide a succinct answer. 1.03. What is the ratio of the Employment (as % of total employment) in Self-employed in 2010 to that in 2011?
Offer a terse response. 0.51. What is the ratio of the Employment (as % of total employment) of Agriculture in 2010 to that in 2012?
Provide a short and direct response. 1.14. What is the ratio of the Employment (as % of total employment) of Industry in 2010 to that in 2012?
Offer a very short reply. 0.91. What is the ratio of the Employment (as % of total employment) in Services in 2010 to that in 2012?
Your response must be concise. 0.93. What is the ratio of the Employment (as % of total employment) in Self-employed in 2010 to that in 2012?
Your answer should be compact. 0.57. What is the ratio of the Employment (as % of total employment) of Agriculture in 2011 to that in 2012?
Your answer should be compact. 1.09. What is the ratio of the Employment (as % of total employment) of Industry in 2011 to that in 2012?
Offer a terse response. 1.2. What is the ratio of the Employment (as % of total employment) of Services in 2011 to that in 2012?
Your answer should be compact. 0.9. What is the ratio of the Employment (as % of total employment) in Self-employed in 2011 to that in 2012?
Ensure brevity in your answer.  1.13. What is the difference between the highest and the second highest Employment (as % of total employment) in Industry?
Provide a succinct answer. 1.1. What is the difference between the highest and the second highest Employment (as % of total employment) of Services?
Give a very brief answer. 7.2. What is the difference between the highest and the second highest Employment (as % of total employment) of Self-employed?
Keep it short and to the point. 7.3. What is the difference between the highest and the lowest Employment (as % of total employment) of Agriculture?
Ensure brevity in your answer.  31.9. What is the difference between the highest and the lowest Employment (as % of total employment) of Services?
Your answer should be very brief. 29.3. What is the difference between the highest and the lowest Employment (as % of total employment) of Self-employed?
Your answer should be very brief. 24.9. 